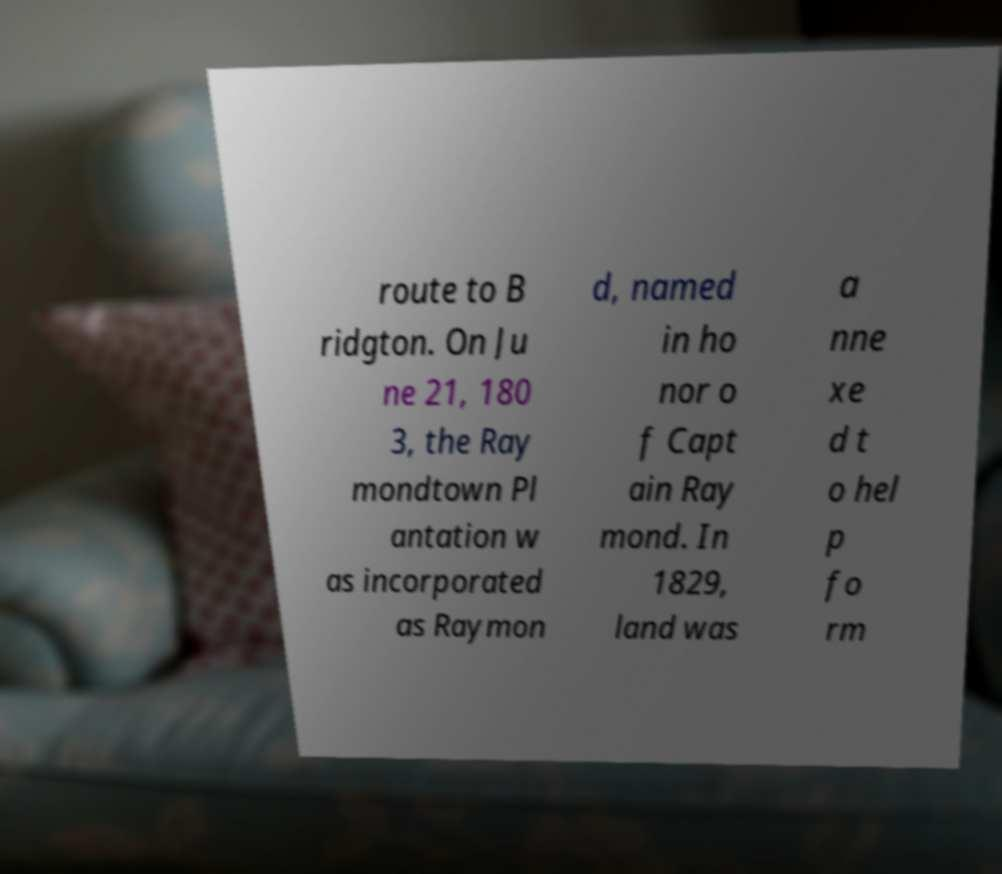Could you assist in decoding the text presented in this image and type it out clearly? route to B ridgton. On Ju ne 21, 180 3, the Ray mondtown Pl antation w as incorporated as Raymon d, named in ho nor o f Capt ain Ray mond. In 1829, land was a nne xe d t o hel p fo rm 